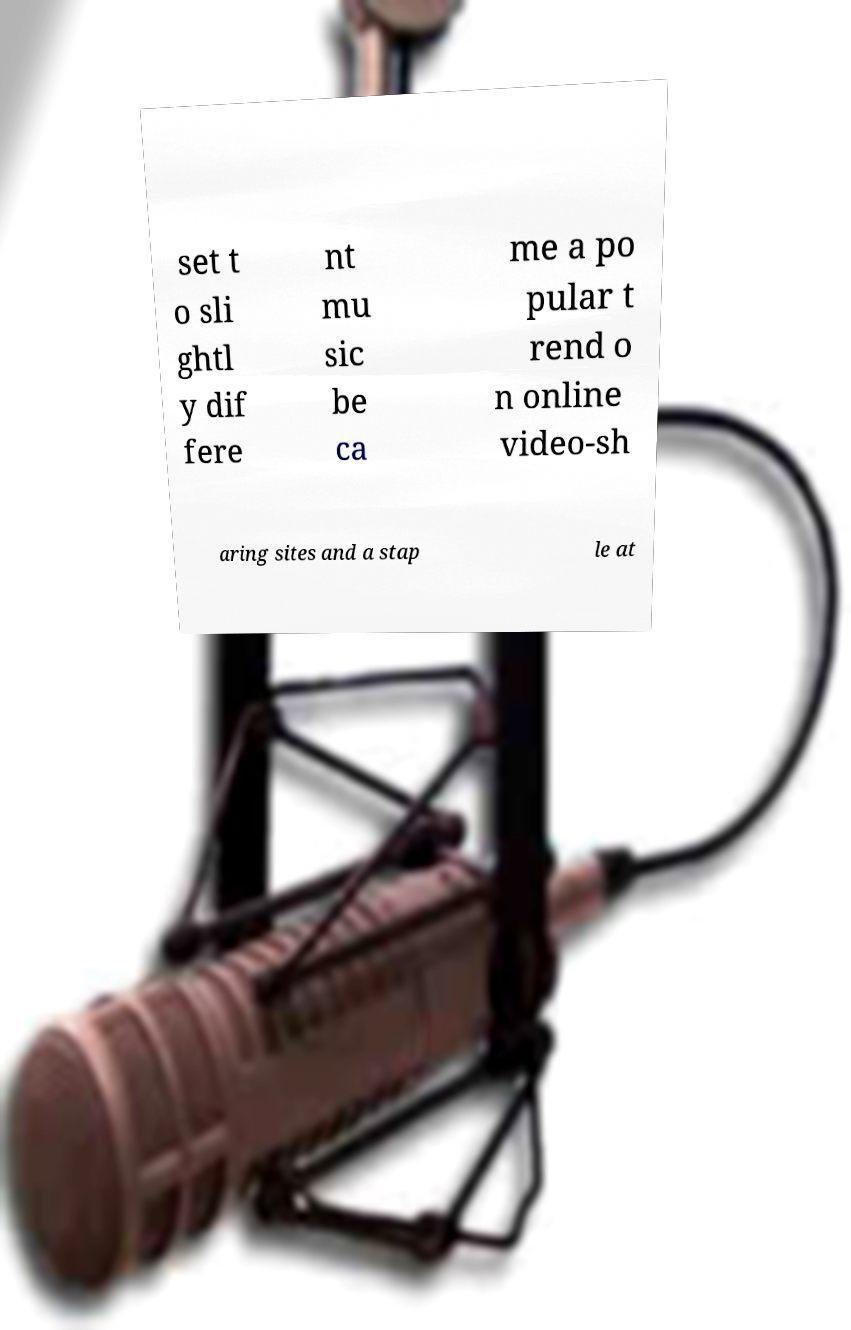Could you assist in decoding the text presented in this image and type it out clearly? set t o sli ghtl y dif fere nt mu sic be ca me a po pular t rend o n online video-sh aring sites and a stap le at 